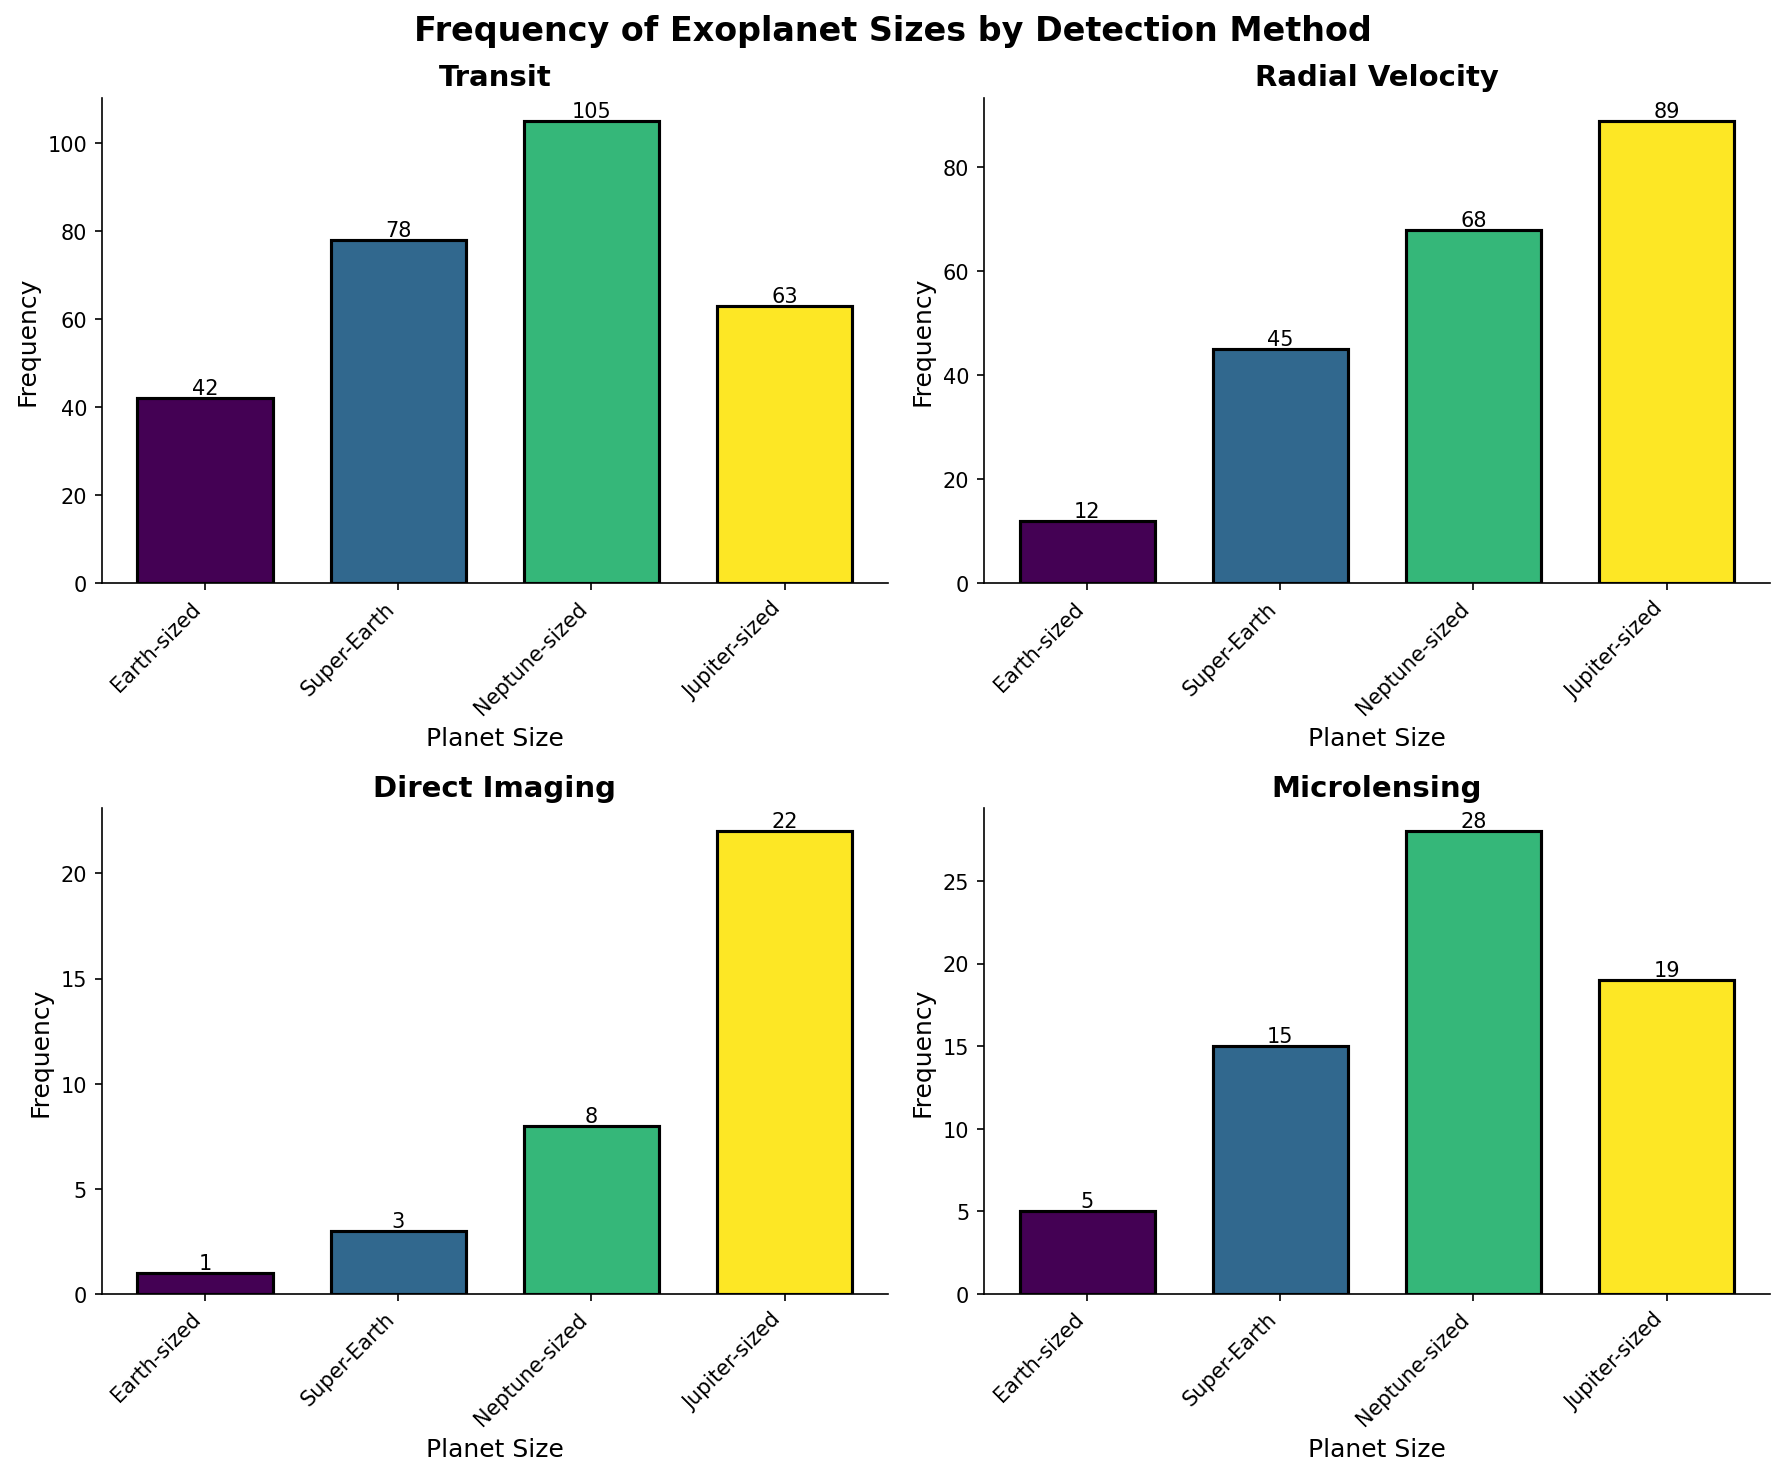What is the title of the figure? The title of the figure is displayed at the top of the plot. It reads "Frequency of Exoplanet Sizes by Detection Method".
Answer: Frequency of Exoplanet Sizes by Detection Method Which detection method discovered the most Neptune-sized planets? The subplot for the "Transit" method has the highest frequency bar for Neptune-sized planets, which is 105.
Answer: Transit What is the total number of Earth-sized exoplanets discovered? Summing the frequencies of Earth-sized exoplanets discovered by all methods: (42 + 12 + 1 + 5)
Answer: 60 Which detection method has the lowest frequency of Super-Earth sized planets? Looking at the subplots, the "Direct Imaging" method has the lowest frequency for Super-Earth sized planets, which is 3.
Answer: Direct Imaging How does the number of Jupiter-sized planets discovered by Radial Velocity compare to those discovered by Transit? Comparing the heights of the bars for Jupiter-sized planets, Radial Velocity has 89 while Transit has 63.
Answer: Radial Velocity has more What is the difference in the number of Earth-sized exoplanets discovered by Transit and Radial Velocity methods? The Transit method discovered 42 Earth-sized exoplanets, and Radial Velocity discovered 12. The difference is 42 - 12.
Answer: 30 Which planet size has the highest cumulative frequency across all detection methods? By comparing the total frequencies for each planet size across all subplots, Neptune-sized has the highest cumulative frequency: (105 + 68 + 8 + 28) = 209.
Answer: Neptune-sized How many detection methods discovered more than 20 Super-Earth sized planets? From the subplots, the methods that discovered more than 20 Super-Earth sized planets are Transit (78) and Radial Velocity (45).
Answer: 2 What is the combined frequency of Jupiter-sized planets discovered by Direct Imaging and Microlensing? Summing the frequencies of Jupiter-sized planets from Direct Imaging (22) and Microlensing (19).
Answer: 41 Which detection method has the most varied discovery counts across different planet sizes? Observing the range of frequencies for each detection method, Transit shows the most variation (ranging from 42 to 105).
Answer: Transit 